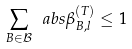<formula> <loc_0><loc_0><loc_500><loc_500>\sum _ { B \in \mathcal { B } } \ a b s { \beta ^ { ( T ) } _ { B , l } } \leq 1</formula> 